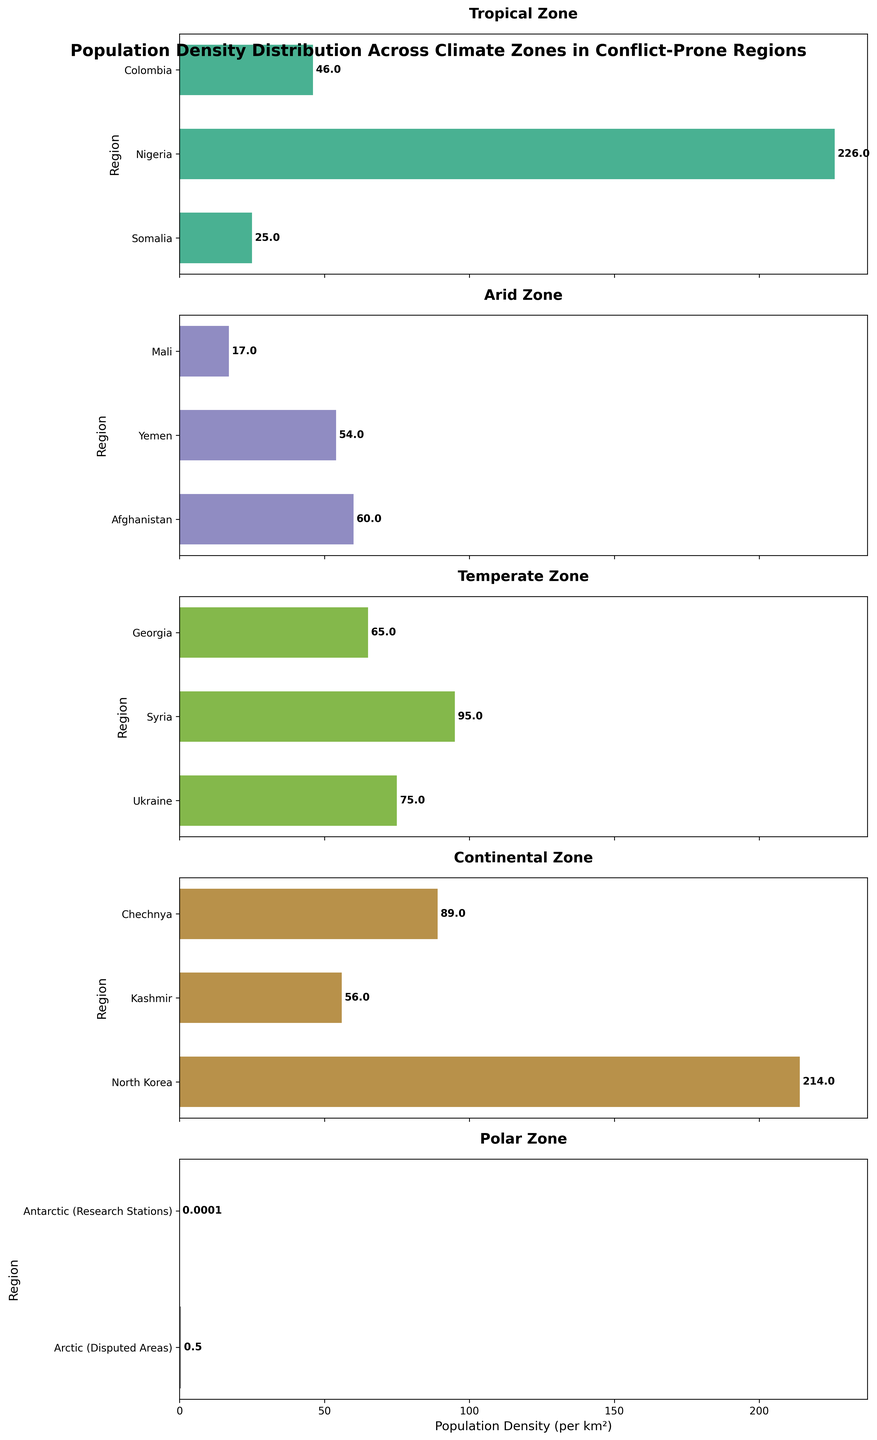What is the title of the figure? The title is usually the first piece of information that gives context to the figure. It is often displayed prominently at the top of the figure.
Answer: Population Density Distribution Across Climate Zones in Conflict-Prone Regions Which region in the Polar zone has the highest population density? To determine this, look at the Polar zone subplot and identify the bar with the highest value.
Answer: Arctic (Disputed Areas) What is the population density of Yemen? Locate Yemen in the Arid zone subplot and read the corresponding population density from the bar.
Answer: 54 Which climate zone has the least variation in population density? Compare the range of population densities across different climate zones by observing the lengths of the bars in each subplot. The zone with the most similar bar lengths has the least variation.
Answer: Polar Which region has the highest population density among all zones? Identify the region with the longest bar across all subplots.
Answer: Nigeria How does the population density of Chechnya compare to North Korea? Compare the lengths of the bars for Chechnya and North Korea in the Continental zone subplot.
Answer: North Korea has a higher population density What is the average population density for regions in the Continental zone? Add up the population densities of North Korea, Kashmir, and Chechnya, then divide by the number of regions (3). Calculations: (214 + 56 + 89) / 3 = 359 / 3.
Answer: 119.67 Which climate zone has the highest average population density? Calculate the average population density for each climate zone and compare. Tropical: (25 + 226 + 46)/3 = 99; Arid: (60 + 54 + 17)/3 = 43.67; Temperate: (75 + 95 + 65)/3 = 78.33; Continental: (214 + 56 + 89)/3 = 119.67; Polar: (0.5 + 0.0001)/2 = 0.25005.
Answer: Continental What is the range of population densities in the Temperate zone? Subtract the lowest population density in the Temperate zone from the highest. The highest value is 95 (Syria) and the lowest is 65 (Georgia). Calculations: 95 - 65 = 30.
Answer: 30 In which climate zones are all regions' population densities below 100? Examine each climate zone and identify whether all regions have bars representing population densities below 100.
Answer: Arid and Polar 